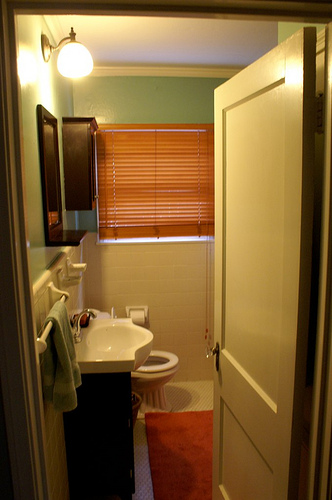Can you describe the flooring? The flooring appears to be a reddish-brown hardwood or laminate, adding warmth to the bathroom. Additionally, a bath mat is placed near the entrance, providing extra comfort and safety. 